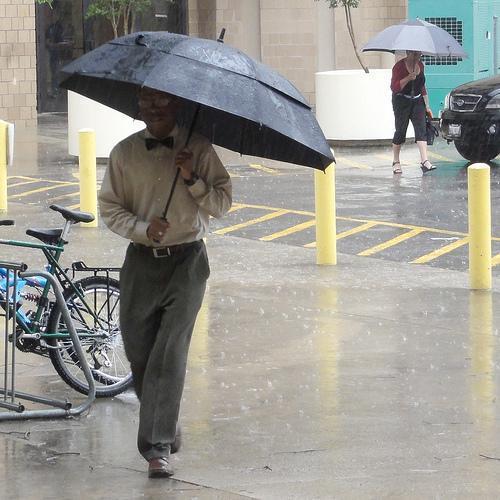How many umbrella's are there?
Give a very brief answer. 1. How many people are pictured?
Give a very brief answer. 2. How many bikes are there?
Give a very brief answer. 2. 